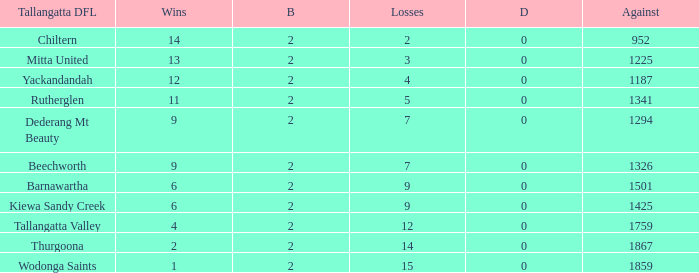What are the draws when wins are fwewer than 9 and byes fewer than 2? 0.0. 